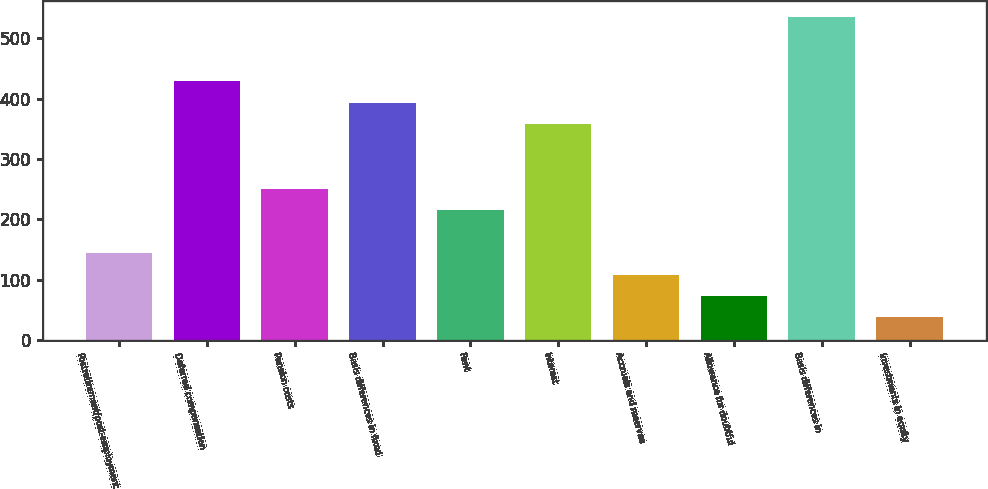Convert chart. <chart><loc_0><loc_0><loc_500><loc_500><bar_chart><fcel>Postretirement/post-employment<fcel>Deferred compensation<fcel>Pension costs<fcel>Basis differences in fixed<fcel>Rent<fcel>Interest<fcel>Accruals and reserves<fcel>Allowance for doubtful<fcel>Basis differences in<fcel>Investments in equity<nl><fcel>144.18<fcel>429.14<fcel>251.04<fcel>393.52<fcel>215.42<fcel>357.9<fcel>108.56<fcel>72.94<fcel>536<fcel>37.32<nl></chart> 